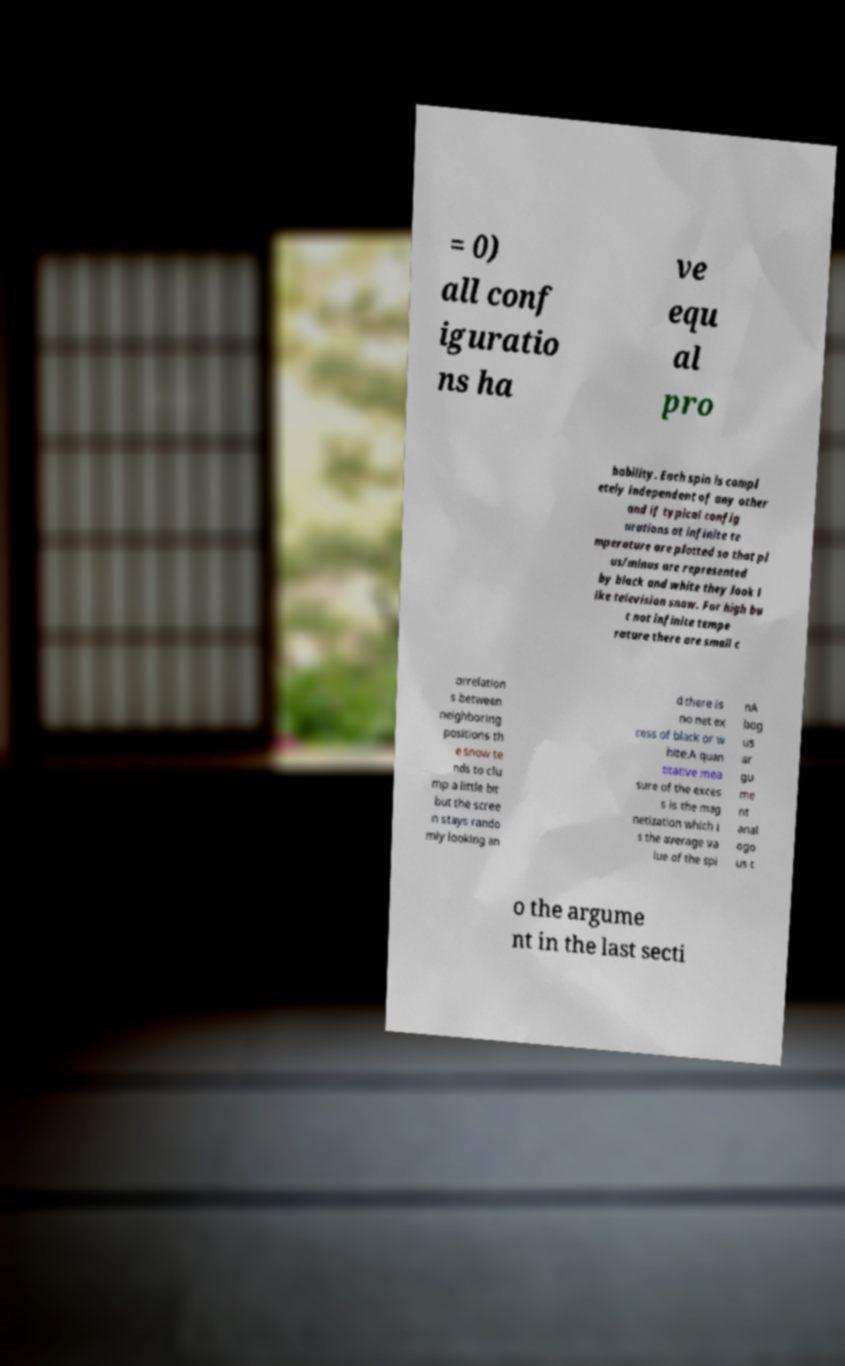Could you assist in decoding the text presented in this image and type it out clearly? = 0) all conf iguratio ns ha ve equ al pro bability. Each spin is compl etely independent of any other and if typical config urations at infinite te mperature are plotted so that pl us/minus are represented by black and white they look l ike television snow. For high bu t not infinite tempe rature there are small c orrelation s between neighboring positions th e snow te nds to clu mp a little bit but the scree n stays rando mly looking an d there is no net ex cess of black or w hite.A quan titative mea sure of the exces s is the mag netization which i s the average va lue of the spi nA bog us ar gu me nt anal ogo us t o the argume nt in the last secti 